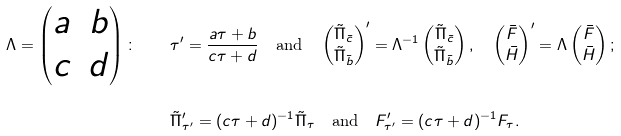<formula> <loc_0><loc_0><loc_500><loc_500>\Lambda = \begin{pmatrix} a & b \\ c & d \end{pmatrix} \colon \quad & \tau ^ { \prime } = \frac { a \tau + b } { c \tau + d } \quad \text {and} \quad \begin{pmatrix} \tilde { \Pi } _ { \bar { c } } \\ \tilde { \Pi } _ { \bar { b } } \end{pmatrix} ^ { \prime } = \Lambda ^ { - 1 } \begin{pmatrix} \tilde { \Pi } _ { \bar { c } } \\ \tilde { \Pi } _ { \bar { b } } \end{pmatrix} , \quad \begin{pmatrix} \bar { F } \\ \bar { H } \end{pmatrix} ^ { \prime } = \Lambda \begin{pmatrix} \bar { F } \\ \bar { H } \end{pmatrix} ; \\ & \tilde { \Pi } _ { \tau ^ { \prime } } ^ { \prime } = ( c \tau + d ) ^ { - 1 } \tilde { \Pi } _ { \tau } \quad \text {and} \quad F _ { \tau ^ { \prime } } ^ { \prime } = ( c \tau + d ) ^ { - 1 } F _ { \tau } .</formula> 